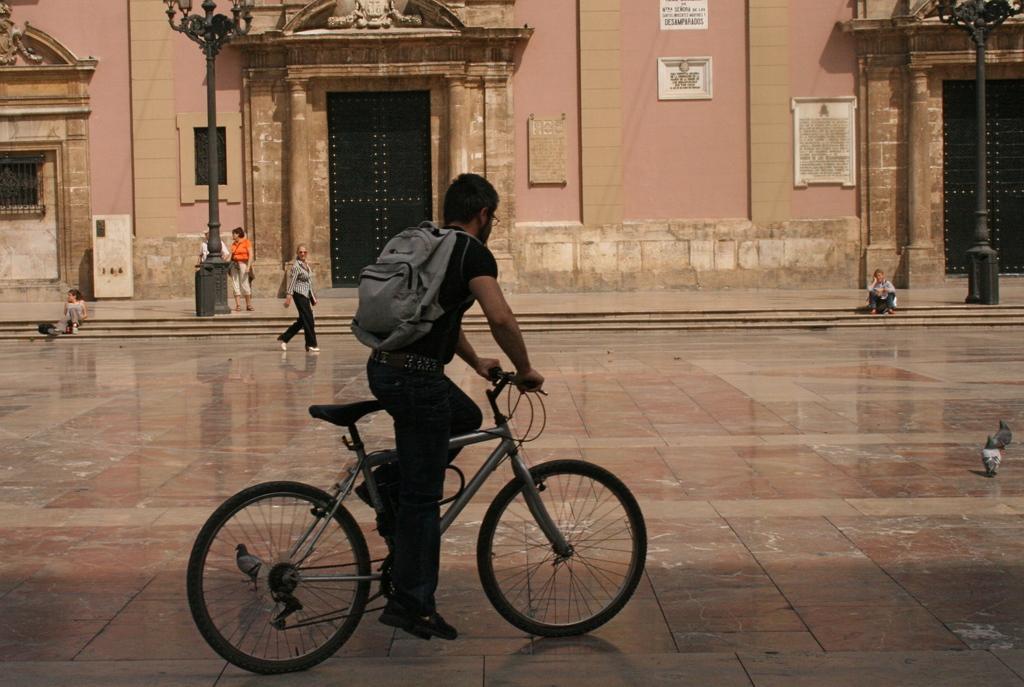Describe this image in one or two sentences. This is a building with window and doors. We can see persons standing near to the building and few are sitting on stairs. One woman is walking. We can see a man wearing a backpack and riding a bicycle. 